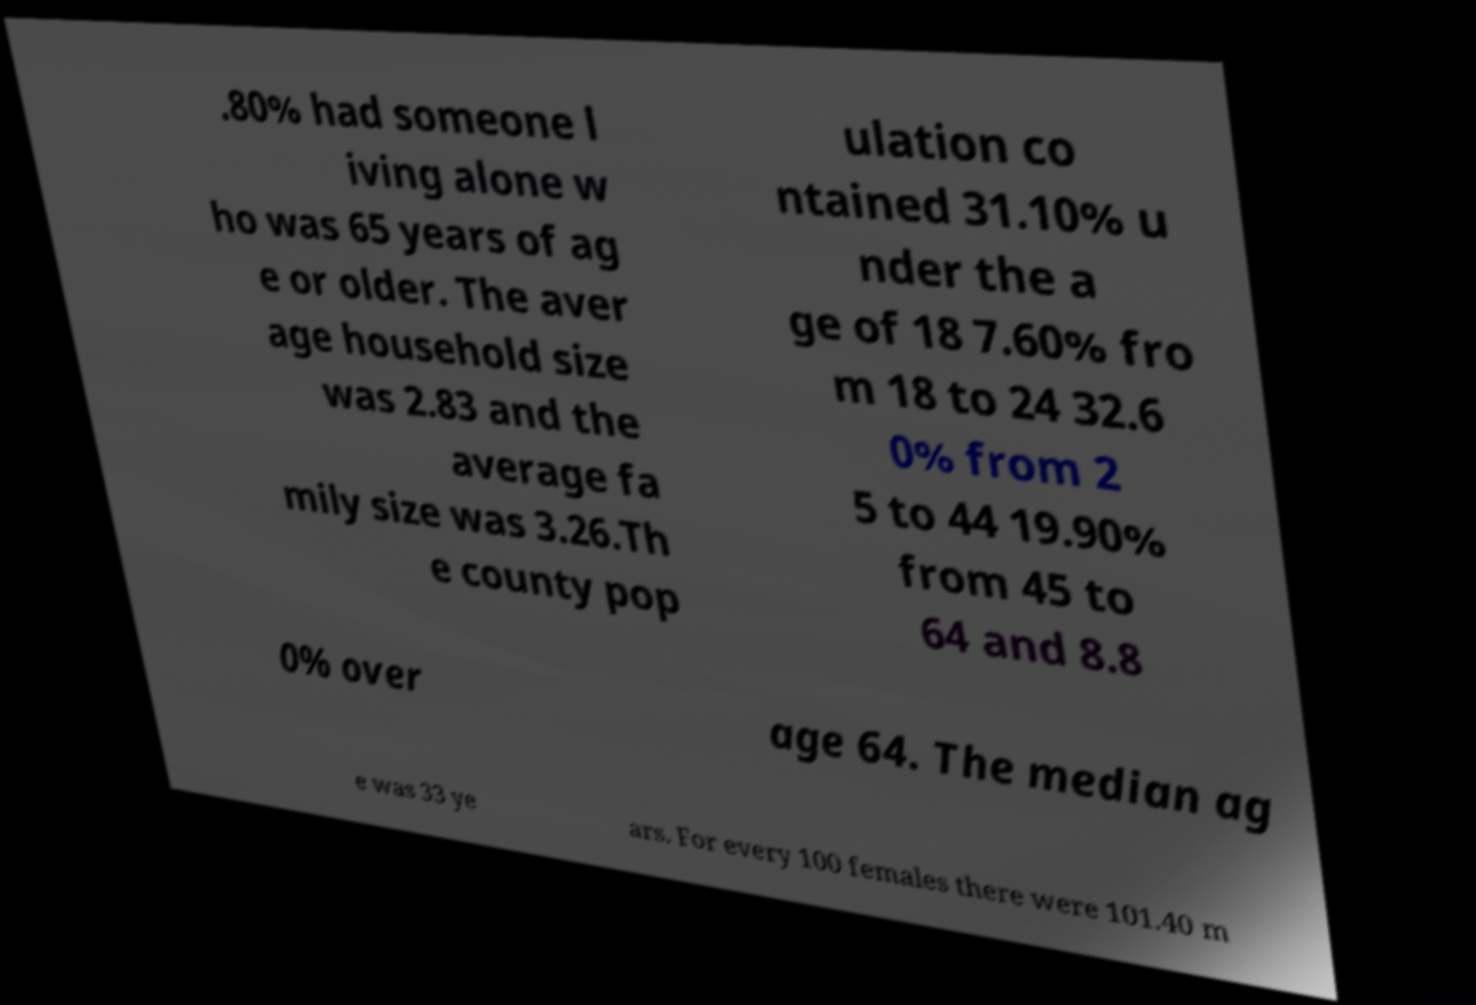Can you read and provide the text displayed in the image?This photo seems to have some interesting text. Can you extract and type it out for me? .80% had someone l iving alone w ho was 65 years of ag e or older. The aver age household size was 2.83 and the average fa mily size was 3.26.Th e county pop ulation co ntained 31.10% u nder the a ge of 18 7.60% fro m 18 to 24 32.6 0% from 2 5 to 44 19.90% from 45 to 64 and 8.8 0% over age 64. The median ag e was 33 ye ars. For every 100 females there were 101.40 m 